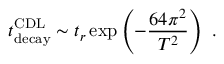<formula> <loc_0><loc_0><loc_500><loc_500>t _ { d e c a y } ^ { C D L } \sim t _ { r } \exp \left ( - { \frac { 6 4 \pi ^ { 2 } } { T ^ { 2 } } } \right ) \ .</formula> 